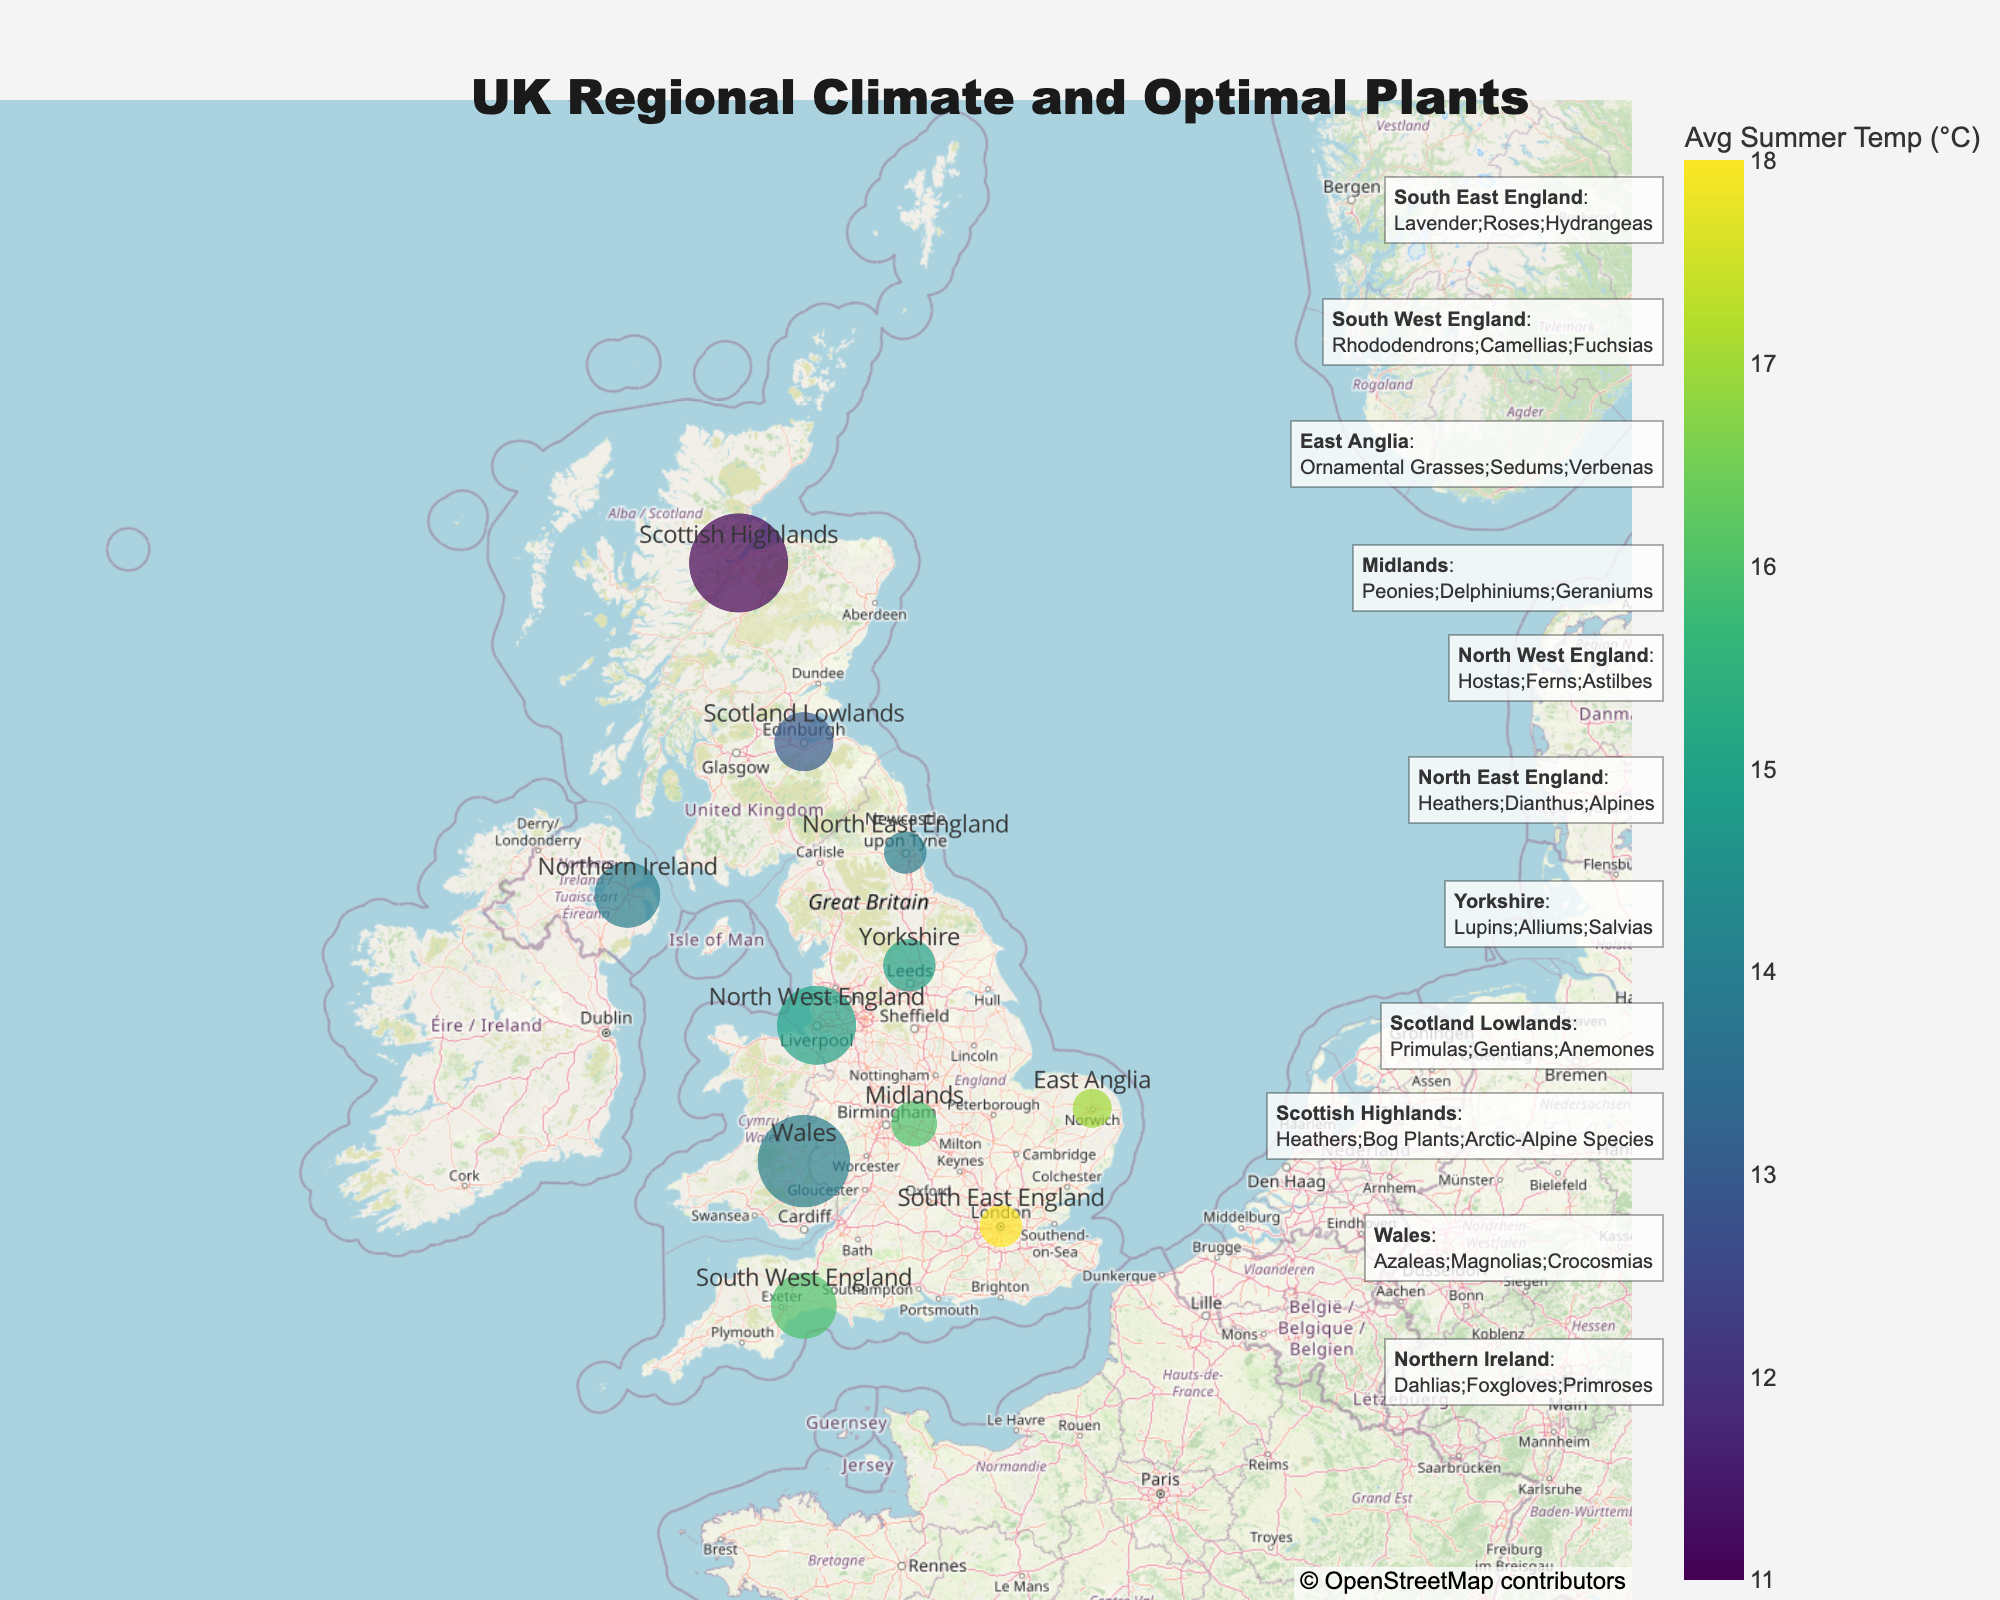what is the average summer temperature in South West England? Look at the average summer temperature value for South West England in the figure.
Answer: 16°C Which region has the highest annual rainfall? Compare the average annual rainfall values of all the regions and identify the one with the highest value.
Answer: Scottish Highlands Which regions have an average annual rainfall above 1000 mm? Identify the regions from the figure with annual rainfall values greater than 1000 mm.
Answer: South West England, North West England, Wales, Scottish Highlands, Northern Ireland Which region has a lower average summer temperature: East Anglia or Yorkshire? Compare the average summer temperature values of East Anglia and Yorkshire.
Answer: Yorkshire What's the median value of the average annual rainfall across all regions? Arrange the average annual rainfall values in ascending order and find the median value. The sorted values are 600, 650, 650, 700, 800, 900, 1000, 1000, 1200, 1400, 1500. The median value (middle value) is the 6th value, which is 900 mm.
Answer: 900 mm What is the color representation based on in the figure? Determine what variable is used to determine the color of the markers on the map.
Answer: Average summer temperature Which region is more optimal for growing Rhododendrons: South East England or South West England? Analyze the optimal plant varieties for both South East England and South West England as shown in the figure.
Answer: South West England What is the difference in average annual rainfall between Scotland Lowlands and Scotland Highlands? Subtract the average annual rainfall value of Scotland Lowlands from that of Scotland Highlands.
Answer: 600 mm Which region lies at the northernmost point on the map? Examine the geographical locations on the map and identify the region located furthest north.
Answer: Scottish Highlands List three regions with average summer temperatures at or below 14°C and name a plant variety optimal for each. Identify regions with average summer temperatures of 14°C or lower and list one plant variety from the optimal plant varieties for each region.
Answer: North East England (Heathers), Scotland Lowlands (Primulas), Northern Ireland (Dahlias) 